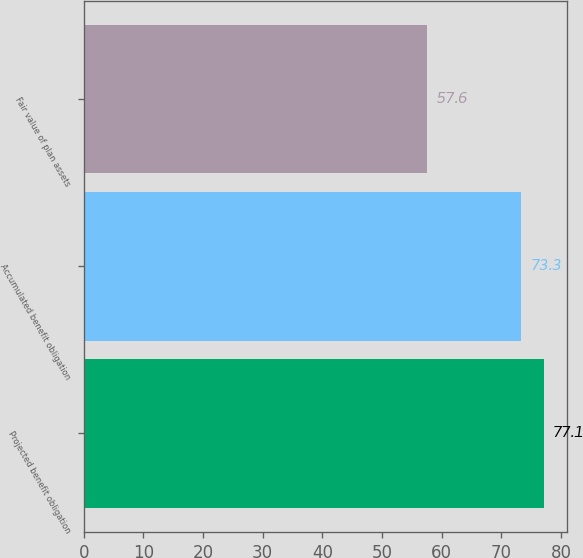<chart> <loc_0><loc_0><loc_500><loc_500><bar_chart><fcel>Projected benefit obligation<fcel>Accumulated benefit obligation<fcel>Fair value of plan assets<nl><fcel>77.1<fcel>73.3<fcel>57.6<nl></chart> 